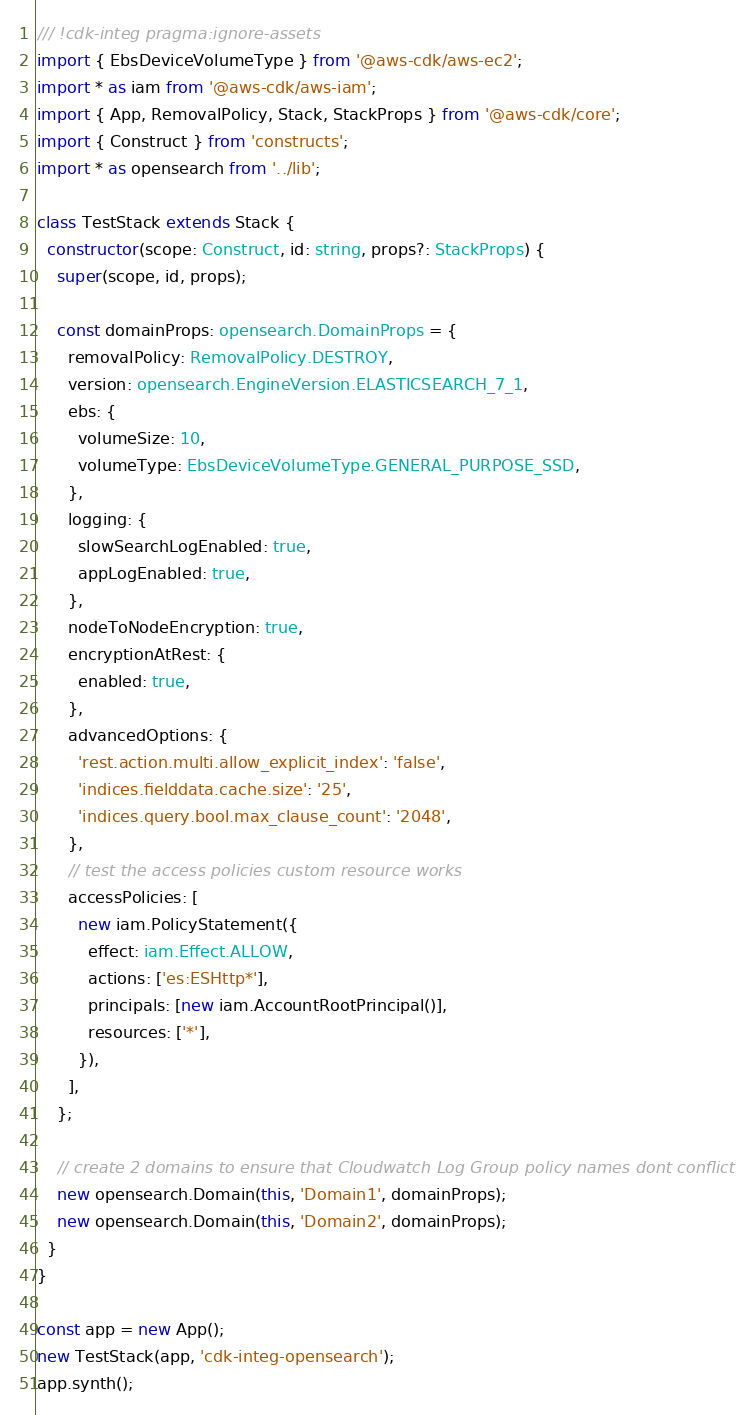Convert code to text. <code><loc_0><loc_0><loc_500><loc_500><_TypeScript_>/// !cdk-integ pragma:ignore-assets
import { EbsDeviceVolumeType } from '@aws-cdk/aws-ec2';
import * as iam from '@aws-cdk/aws-iam';
import { App, RemovalPolicy, Stack, StackProps } from '@aws-cdk/core';
import { Construct } from 'constructs';
import * as opensearch from '../lib';

class TestStack extends Stack {
  constructor(scope: Construct, id: string, props?: StackProps) {
    super(scope, id, props);

    const domainProps: opensearch.DomainProps = {
      removalPolicy: RemovalPolicy.DESTROY,
      version: opensearch.EngineVersion.ELASTICSEARCH_7_1,
      ebs: {
        volumeSize: 10,
        volumeType: EbsDeviceVolumeType.GENERAL_PURPOSE_SSD,
      },
      logging: {
        slowSearchLogEnabled: true,
        appLogEnabled: true,
      },
      nodeToNodeEncryption: true,
      encryptionAtRest: {
        enabled: true,
      },
      advancedOptions: {
        'rest.action.multi.allow_explicit_index': 'false',
        'indices.fielddata.cache.size': '25',
        'indices.query.bool.max_clause_count': '2048',
      },
      // test the access policies custom resource works
      accessPolicies: [
        new iam.PolicyStatement({
          effect: iam.Effect.ALLOW,
          actions: ['es:ESHttp*'],
          principals: [new iam.AccountRootPrincipal()],
          resources: ['*'],
        }),
      ],
    };

    // create 2 domains to ensure that Cloudwatch Log Group policy names dont conflict
    new opensearch.Domain(this, 'Domain1', domainProps);
    new opensearch.Domain(this, 'Domain2', domainProps);
  }
}

const app = new App();
new TestStack(app, 'cdk-integ-opensearch');
app.synth();
</code> 